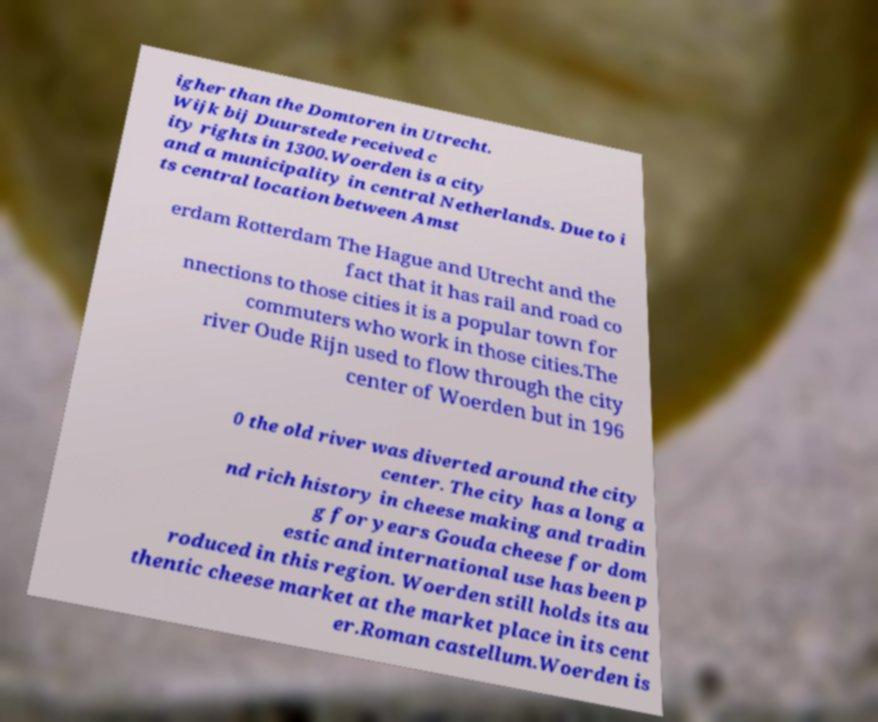What messages or text are displayed in this image? I need them in a readable, typed format. igher than the Domtoren in Utrecht. Wijk bij Duurstede received c ity rights in 1300.Woerden is a city and a municipality in central Netherlands. Due to i ts central location between Amst erdam Rotterdam The Hague and Utrecht and the fact that it has rail and road co nnections to those cities it is a popular town for commuters who work in those cities.The river Oude Rijn used to flow through the city center of Woerden but in 196 0 the old river was diverted around the city center. The city has a long a nd rich history in cheese making and tradin g for years Gouda cheese for dom estic and international use has been p roduced in this region. Woerden still holds its au thentic cheese market at the market place in its cent er.Roman castellum.Woerden is 